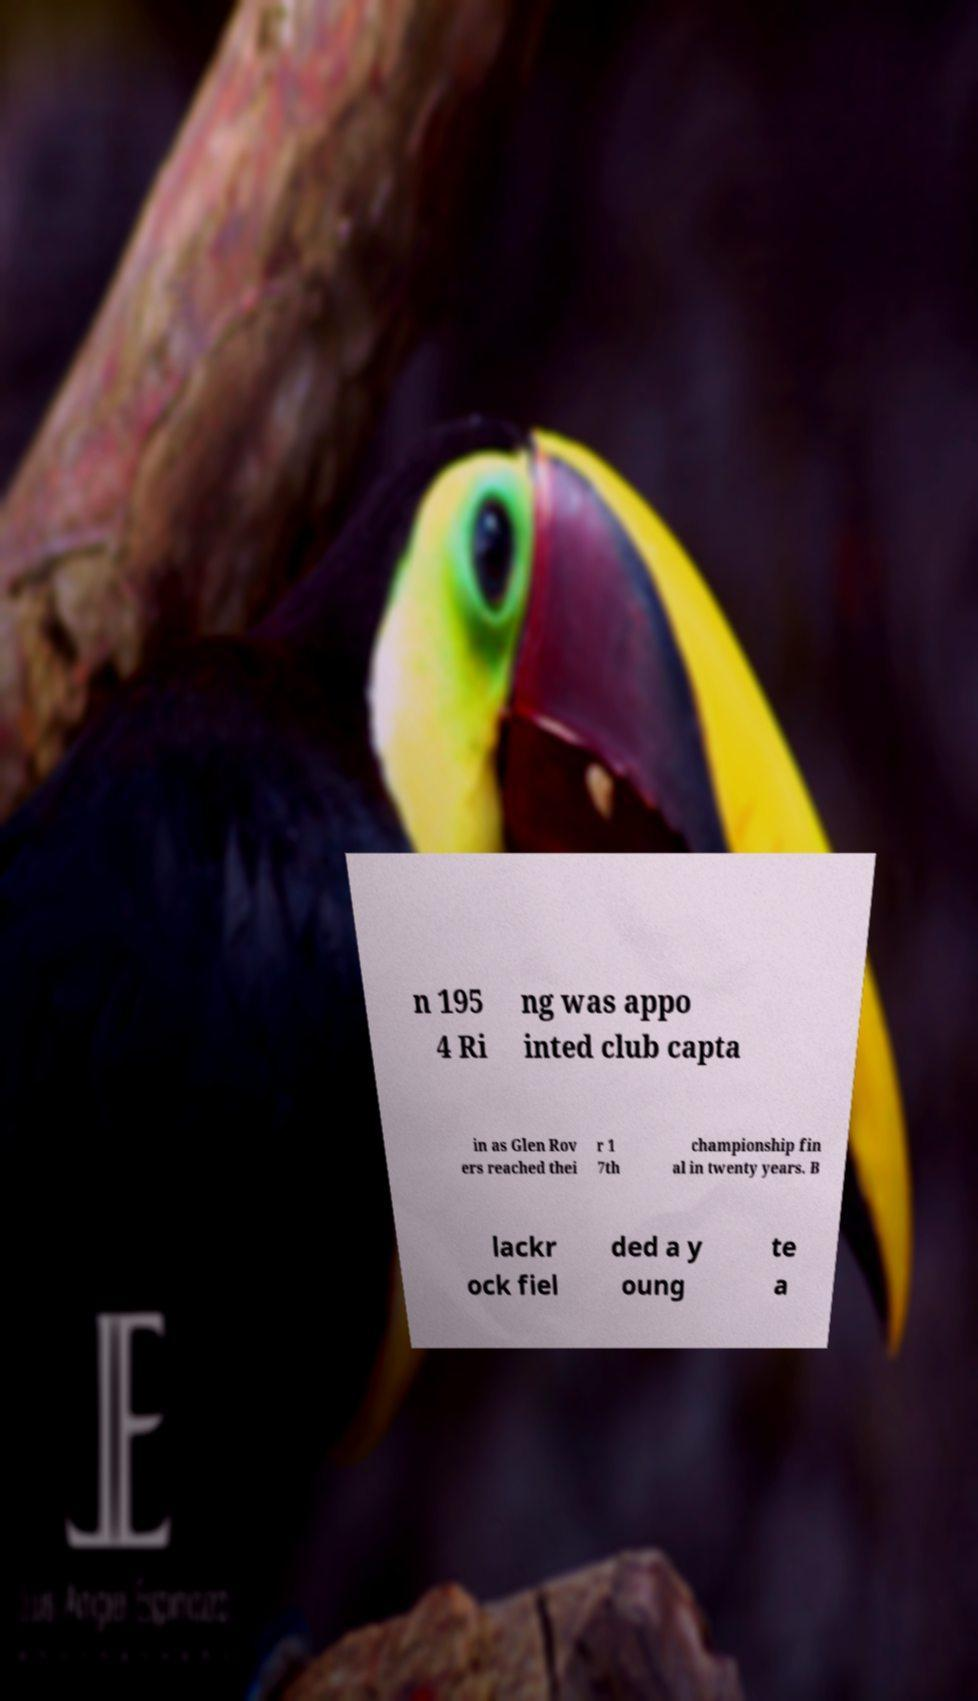Please read and relay the text visible in this image. What does it say? n 195 4 Ri ng was appo inted club capta in as Glen Rov ers reached thei r 1 7th championship fin al in twenty years. B lackr ock fiel ded a y oung te a 